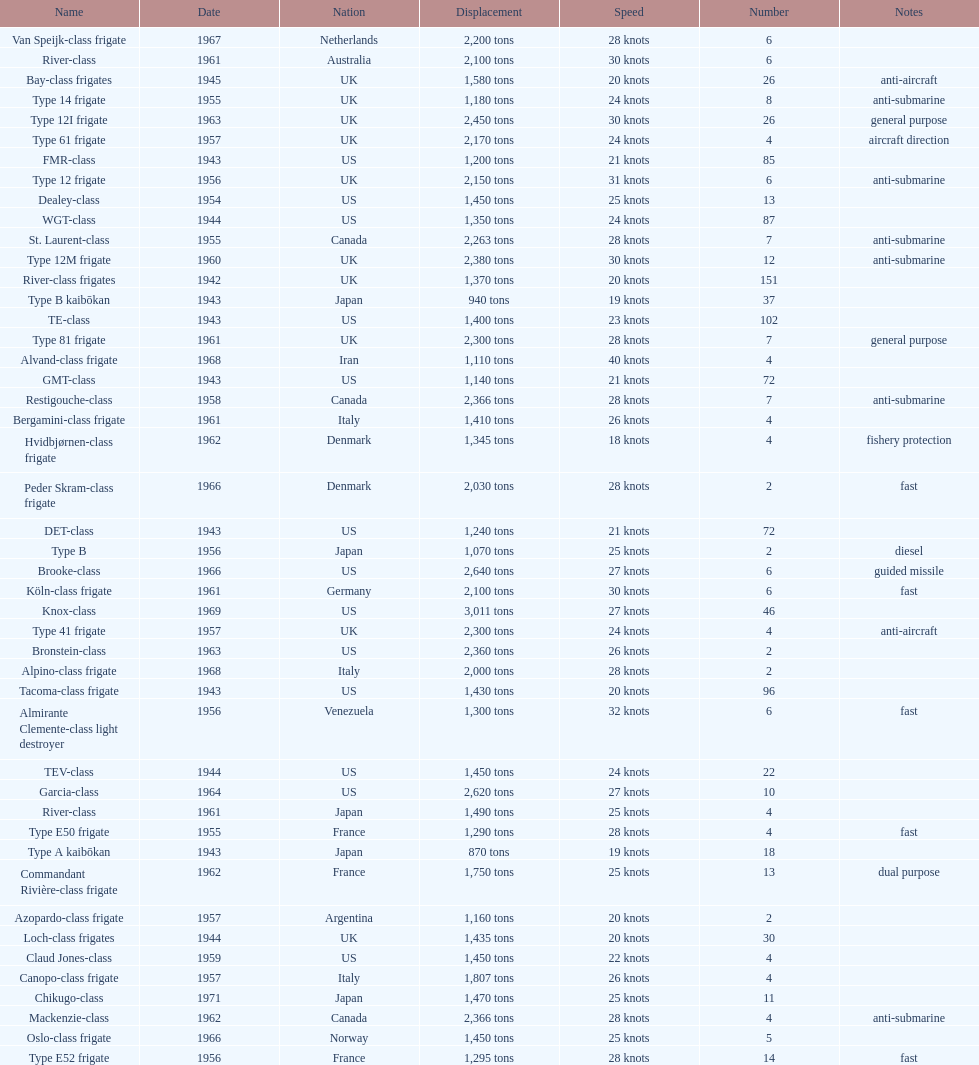How many consecutive escorts were in 1943? 7. 